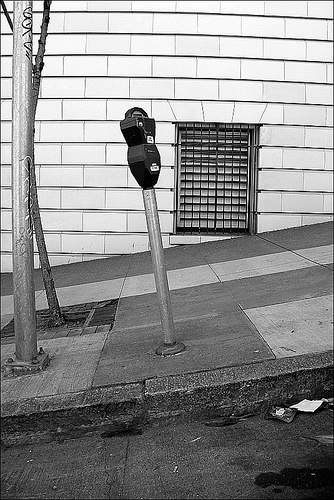Describe the objects in this image and their specific colors. I can see a parking meter in black, gray, darkgray, and white tones in this image. 